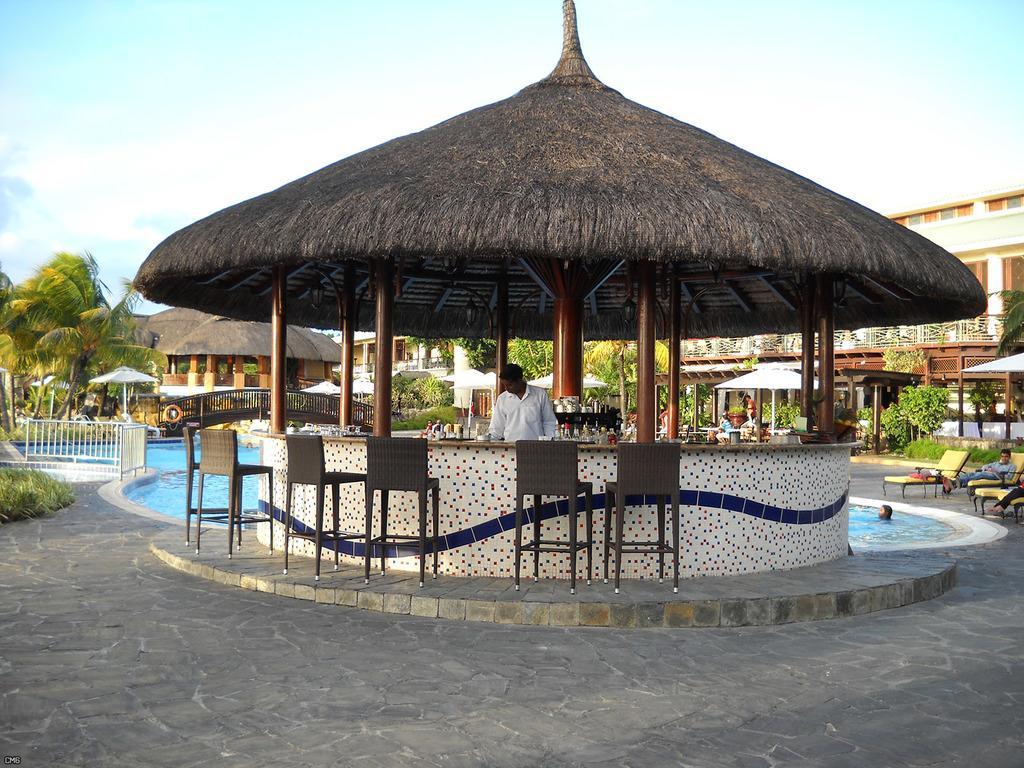Please provide a concise description of this image. In this image, we can see buildings, huts and there are umbrellas, chairs and we can see some objects on the stands and there are railings, trees and some people. At the top, there is sky and at the bottom, there is water and a road. 